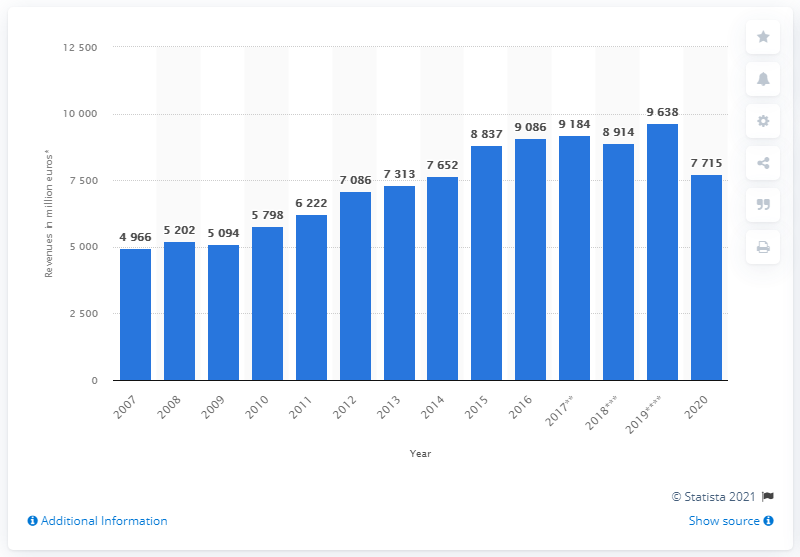Indicate a few pertinent items in this graphic. In 2020, Luxottica's global revenue was 7,715. 